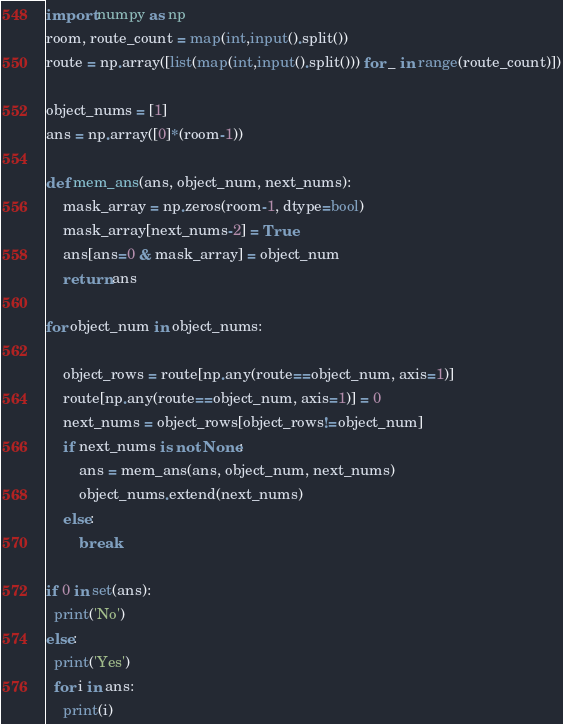<code> <loc_0><loc_0><loc_500><loc_500><_Python_>import numpy as np
room, route_count = map(int,input().split())
route = np.array([list(map(int,input().split())) for _ in range(route_count)])
 
object_nums = [1]
ans = np.array([0]*(room-1))
 
def mem_ans(ans, object_num, next_nums):
    mask_array = np.zeros(room-1, dtype=bool)
    mask_array[next_nums-2] = True
    ans[ans=0 & mask_array] = object_num
    return ans
 
for object_num in object_nums:
 
    object_rows = route[np.any(route==object_num, axis=1)]
    route[np.any(route==object_num, axis=1)] = 0
    next_nums = object_rows[object_rows!=object_num]
    if next_nums is not None:
        ans = mem_ans(ans, object_num, next_nums)
        object_nums.extend(next_nums)
    else:
        break
 
if 0 in set(ans):
  print('No')
else:
  print('Yes')
  for i in ans:
    print(i)</code> 